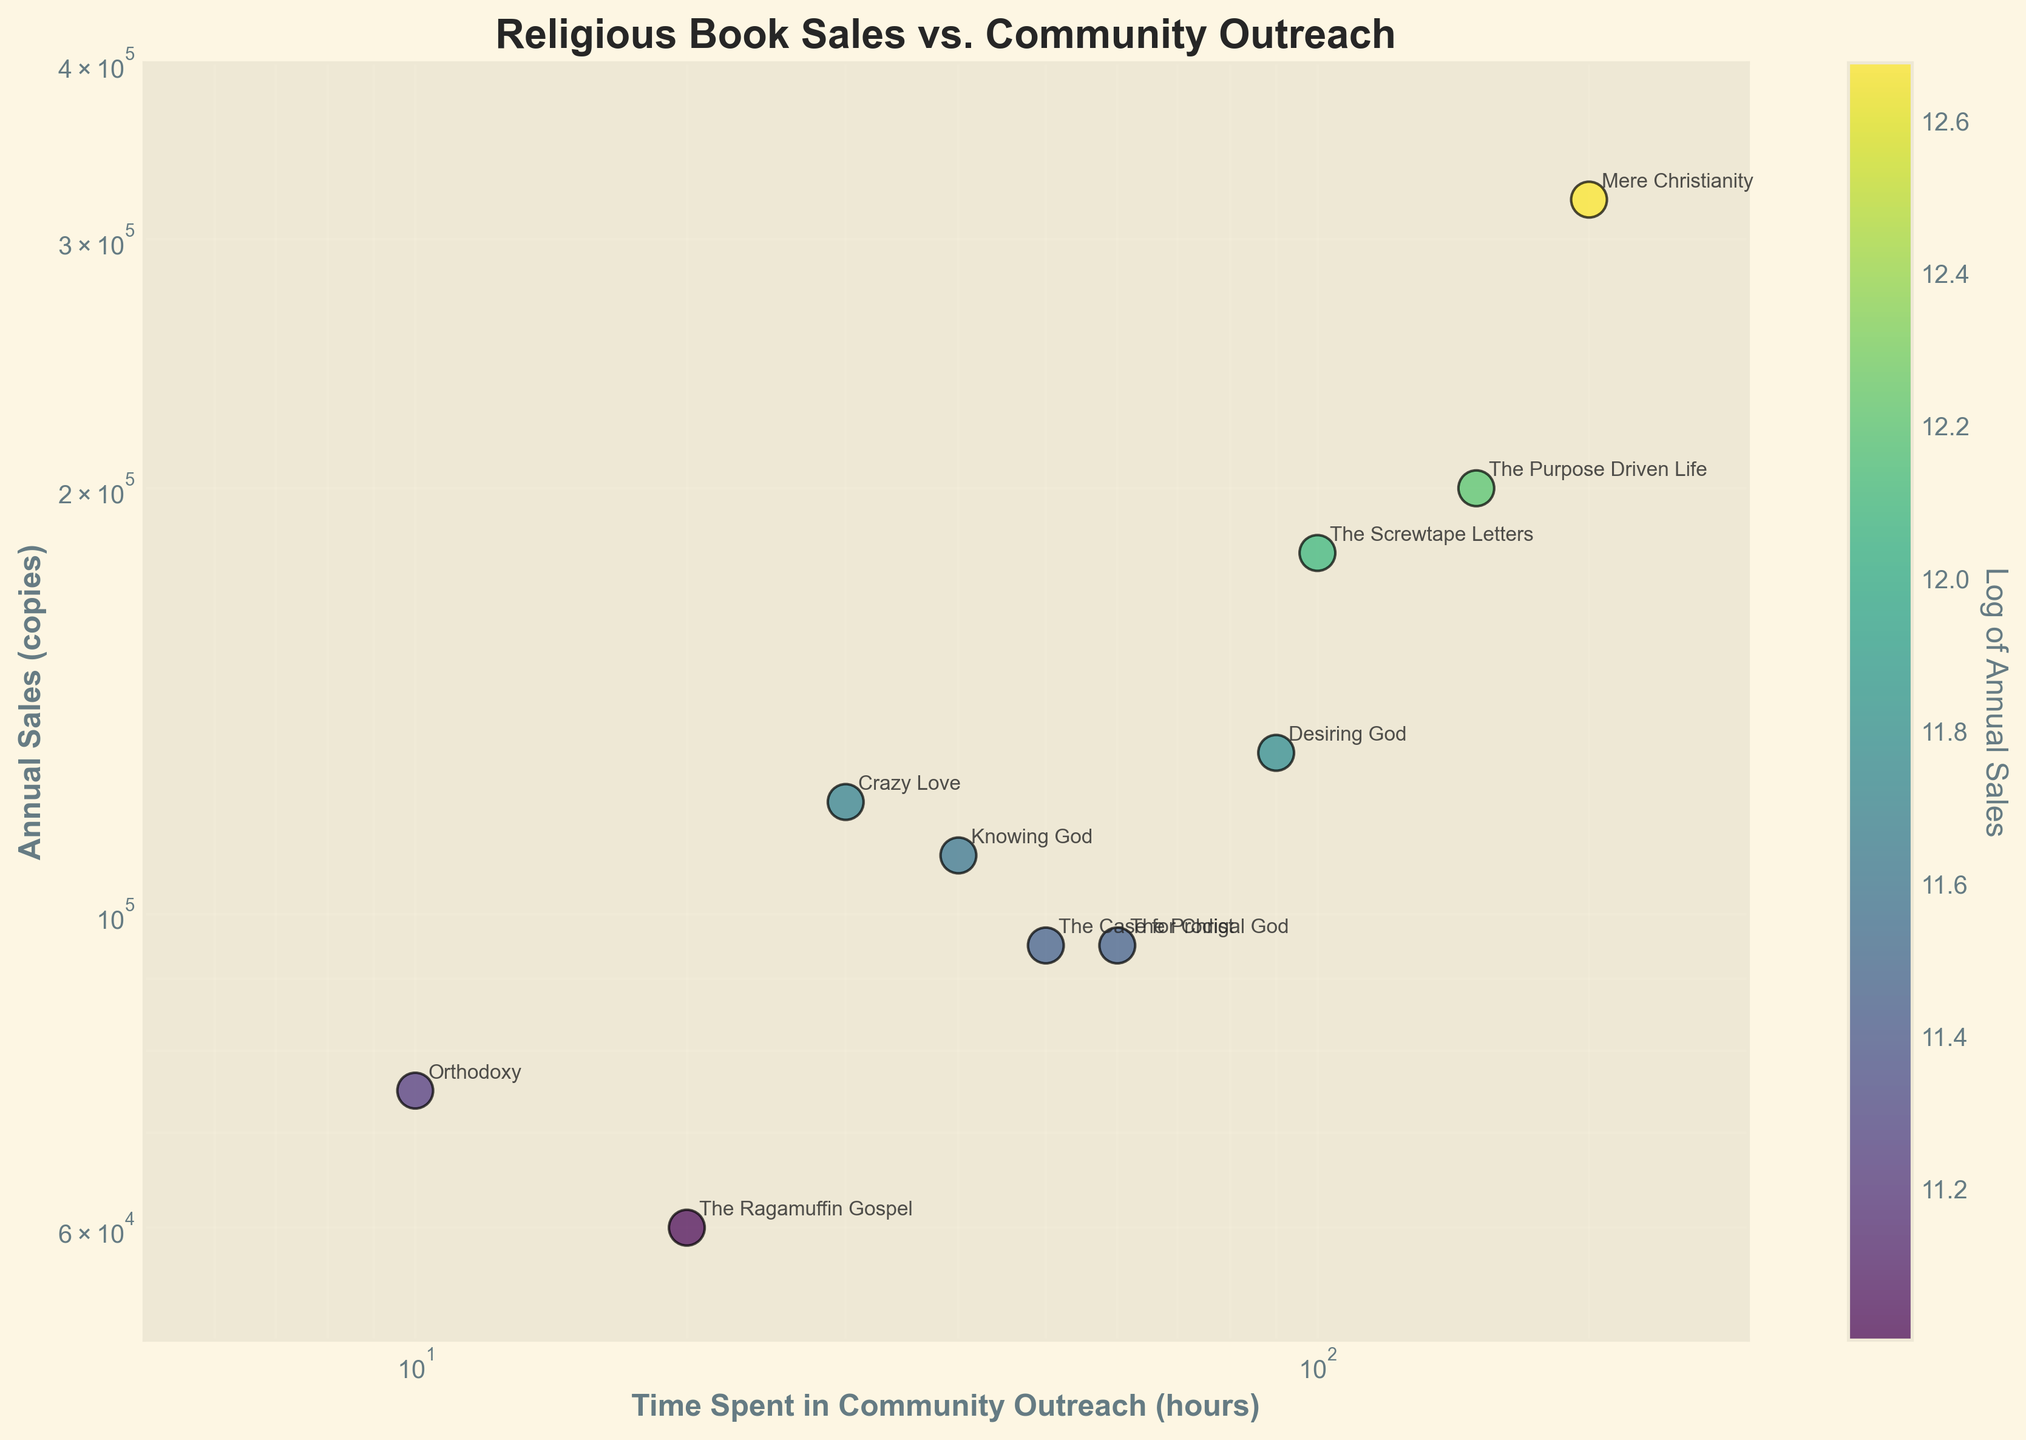What is the title of the plot? The title of the plot is displayed at the top and is clearly stated as "Religious Book Sales vs. Community Outreach".
Answer: Religious Book Sales vs. Community Outreach How many data points are represented in the plot? Each book title corresponds to a single data point on the plot, and there are a total of 10 book titles listed in the dataset.
Answer: 10 Which book has the highest annual sales? By looking at the vertical position of the data points in the plot, "Mere Christianity" is the highest with 320,000 copies sold annually.
Answer: Mere Christianity Which book has the least time spent in community outreach? The horizontal position of the data points with the lowest outreach hours corresponds to "Orthodoxy" at 10 hours.
Answer: Orthodoxy What is the relationship between "The Prodigal God" and "The Case for Christ" in terms of annual sales? "The Prodigal God" (60 hours in outreach) and "The Case for Christ" (50 hours in outreach) both register 95,000 copies in annual sales, placing them at the same vertical position.
Answer: Equal Which book shows a close relationship between time spent in community outreach and annual sales, excluding "Mere Christianity"? Excluding the outlier "Mere Christianity", "The Purpose Driven Life" (150 hours, 200,000 copies) has the next noticeable high correlation between outreach time and sales.
Answer: The Purpose Driven Life Among books with annual sales above 100,000 copies, which one has spent the least time in community outreach? For books with sales above 100,000 copies, "Crazy Love" stands out with 30 hours in outreach activities.
Answer: Crazy Love What is the average annual sales for books with community outreach between 20 and 60 hours? Books in this range are "Crazy Love", "The Case for Christ", "Knowing God", and "The Prodigal God". Their sales values are 120,000, 95,000, 110,000, and 95,000 respectively. Summing these up gives 420,000. Dividing by 4, the average is 105,000 copies.
Answer: 105,000 How does the color of the data points help in understanding the plot? The color of the data points represents the logarithm of annual sales, with a gradient from one color to another indicating different sales levels. This helps visually differentiate books with varying sales figures.
Answer: Color represents log of annual sales Is there a trend between time spent in community outreach and annual sales? There's a general trend indicating that higher time spent in community outreach activities is associated with higher annual sales, although not all data points strictly follow this trend.
Answer: General upward trend 